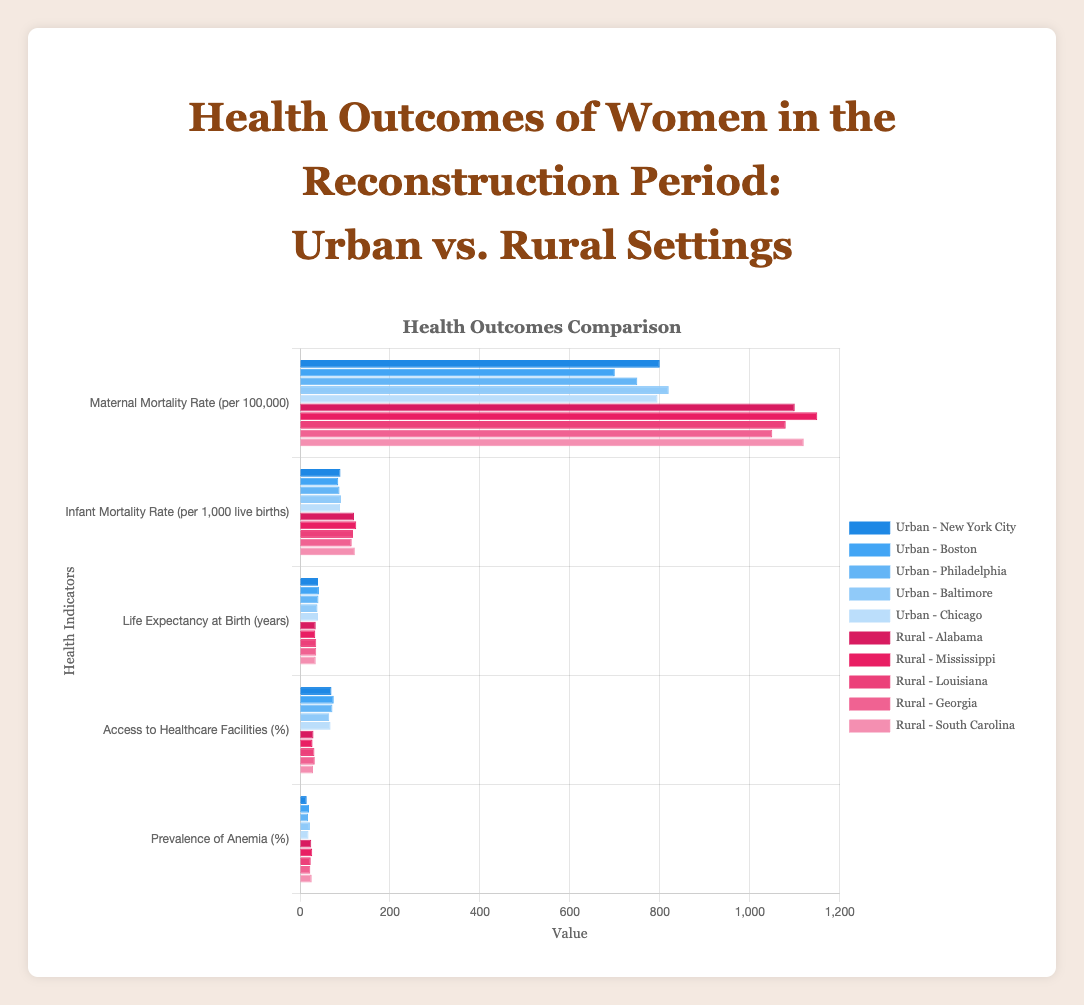What is the difference in the Maternal Mortality Rate between New York City (urban) and Mississippi (rural)? The Maternal Mortality Rate for New York City is 800 per 100,000, while for Mississippi, it is 1150 per 100,000. The difference is calculated as 1150 - 800 = 350
Answer: 350 Which city has the highest Life Expectancy at Birth among the urban areas, and what is its value? In the urban areas, the Life Expectancy at Birth values are New York City (40 years), Boston (42 years), Philadelphia (41 years), Baltimore (39 years), and Chicago (40 years). The highest among these is Boston with 42 years
Answer: Boston, 42 years Does Philadelphia have higher Access to Healthcare Facilities than Baltimore? The Access to Healthcare Facilities percentage for Philadelphia is 72%, while for Baltimore, it is 65%. Philadelphia has a higher percentage of Access to Healthcare Facilities
Answer: Yes What is the average Infant Mortality Rate for the rural cities listed? The Infant Mortality Rates for the rural cities are Alabama (120), Mississippi (125), Louisiana (118), Georgia (115), and South Carolina (122). Summing these up: 120 + 125 + 118 + 115 + 122 = 600, and the average is 600 / 5 = 120
Answer: 120 What is the total Access to Healthcare Facilities percentage for New York City and Boston combined? The Access to Healthcare Facilities percentage for New York City is 70% and for Boston, it is 75%. Adding these together: 70 + 75 = 145
Answer: 145 Which category has the largest gap between urban and rural settings in any city, and what is that gap? Comparing all categories for all cities, the largest gap is in the Access to Healthcare Facilities between Boston (75%) and Mississippi (28%). The gap is calculated as 75 - 28 = 47
Answer: Access to Healthcare Facilities, 47 What is the combined Prevalence of Anemia percentage for the rural cities? The Prevalence of Anemia percentages for rural cities are Alabama (25%), Mississippi (27%), Louisiana (24%), Georgia (23%), and South Carolina (26%). Summing these: 25 + 27 + 24 + 23 + 26 = 125
Answer: 125 Which city has the lowest Prevalence of Anemia among all the cities (urban and rural)? Among all cities, the Prevalence of Anemia percentages are New York City (15%), Boston (20%), Philadelphia (18%), Baltimore (22%), Chicago (19%), Alabama (25%), Mississippi (27%), Louisiana (24%), Georgia (23%), and South Carolina (26%). The lowest percentage is in New York City with 15%
Answer: New York City By how many years does the Life Expectancy at Birth in Boston exceed that of Alabama? The Life Expectancy at Birth is 42 years in Boston and 35 years in Alabama. The difference is calculated as 42 - 35 = 7
Answer: 7 What is the Maternal Mortality Rate in Baltimore relative to the average of the urban cities? The Maternal Mortality Rates in urban areas are New York City (800), Boston (700), Philadelphia (750), Baltimore (820), and Chicago (795). The average is (800 + 700 + 750 + 820 + 795) / 5 = 773. Baltimore's rate is 820. Relative value is calculated as 820 - 773 = 47
Answer: 47 